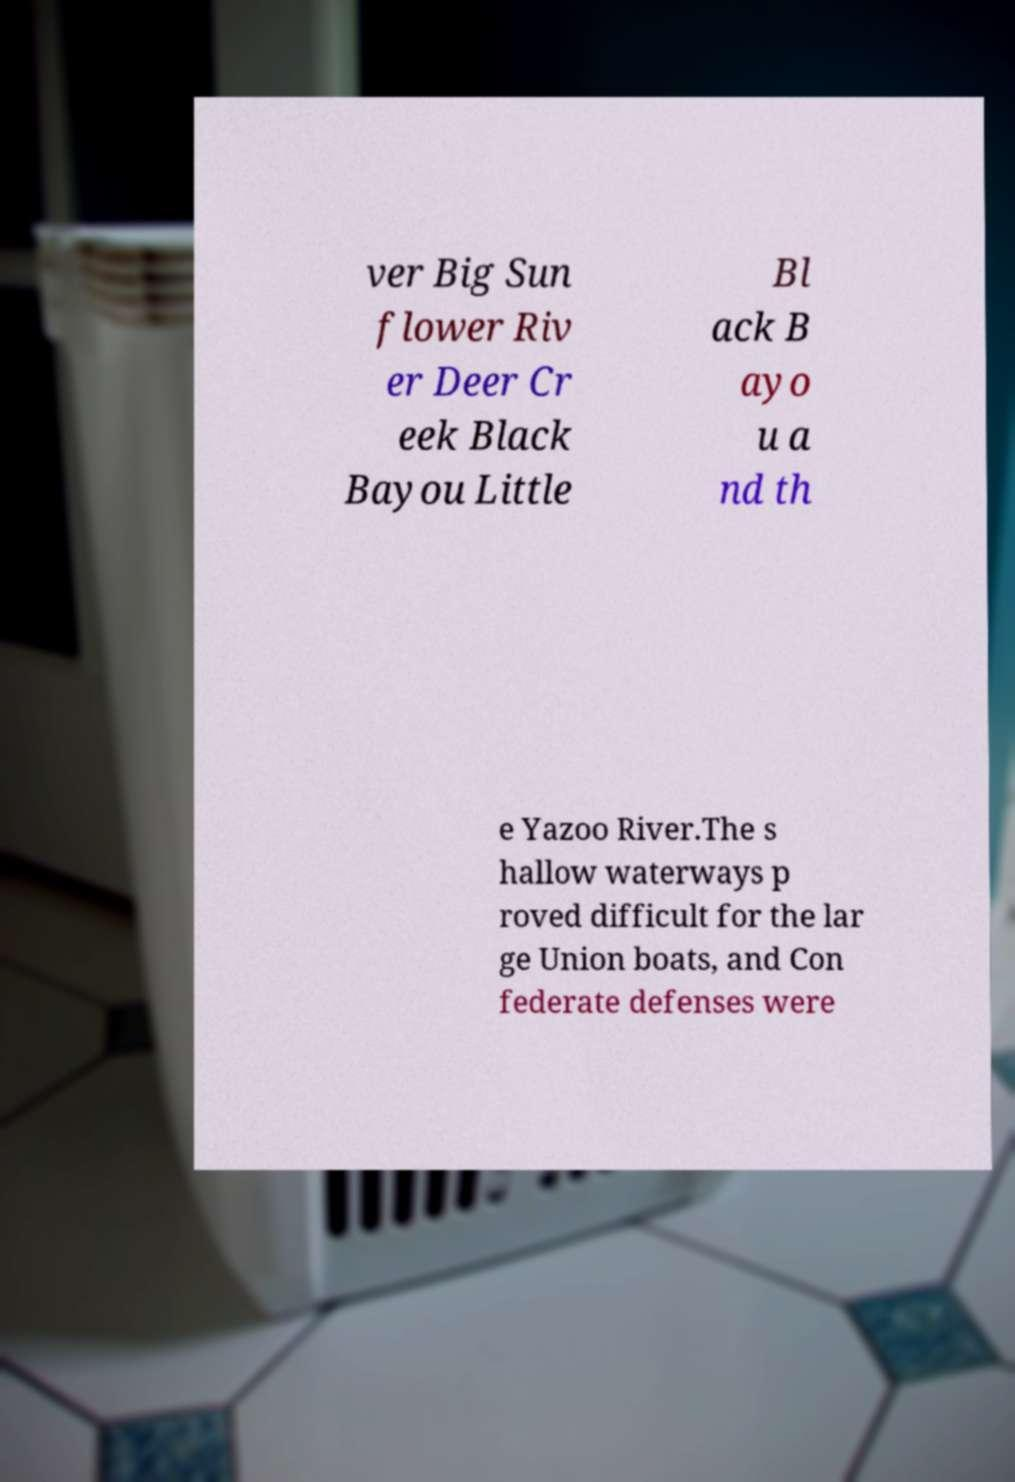I need the written content from this picture converted into text. Can you do that? ver Big Sun flower Riv er Deer Cr eek Black Bayou Little Bl ack B ayo u a nd th e Yazoo River.The s hallow waterways p roved difficult for the lar ge Union boats, and Con federate defenses were 